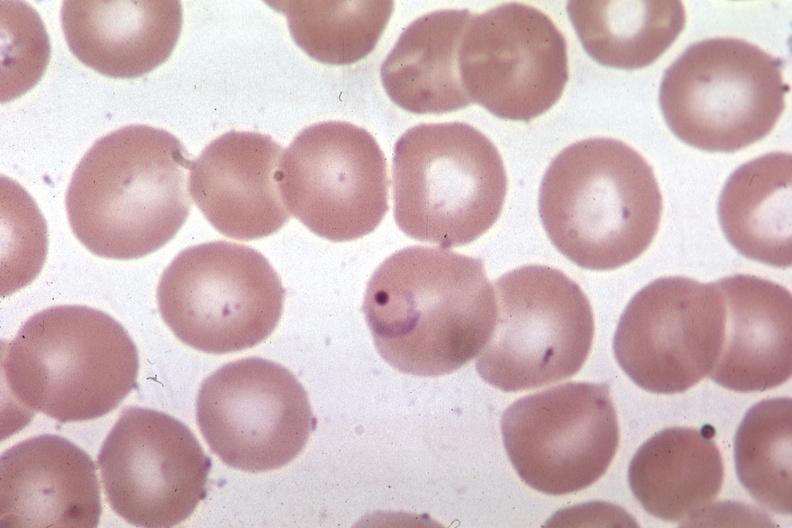s blood present?
Answer the question using a single word or phrase. Yes 